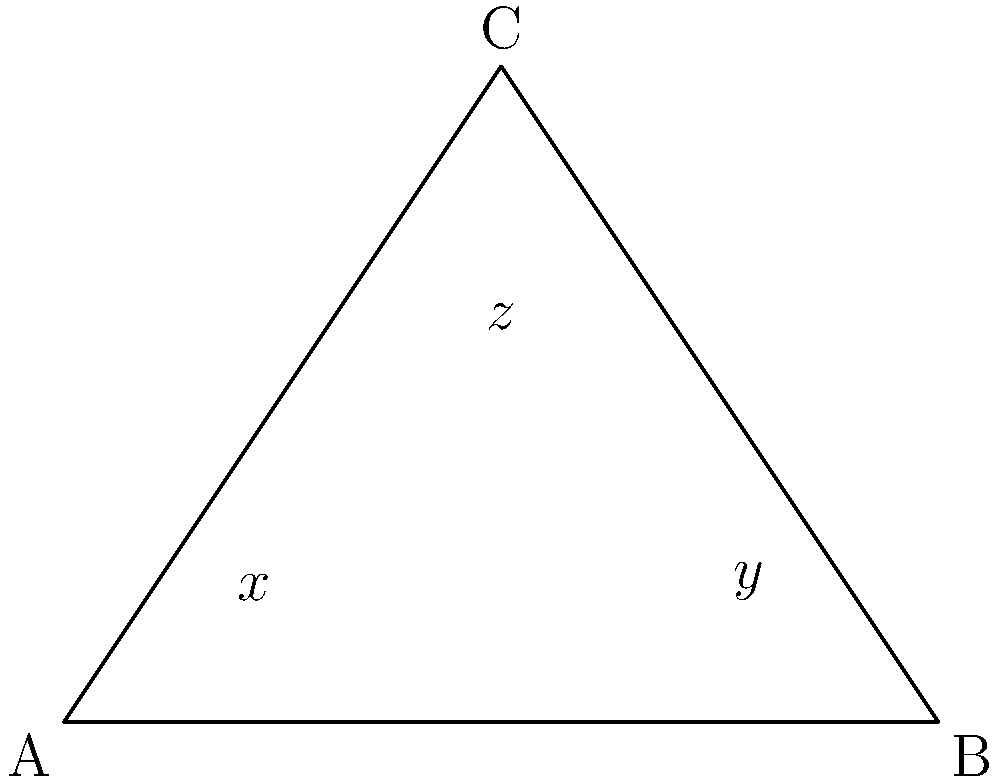In a study of marine species migration patterns affected by pollution, three paths are represented by line segments forming a triangle ABC. The pollution source is located at point C, creating two equal angles $x°$ and $y°$ at the base of the triangle. If the angle at the vertex C is $z°$, what is the value of $z$ in terms of $x$? Let's approach this step-by-step:

1) In any triangle, the sum of all angles is 180°. So we can write:
   
   $x + y + z = 180$ ... (1)

2) We're told that angles $x$ and $y$ are equal. Let's call this common value $x$. So:
   
   $x + x + z = 180$
   $2x + z = 180$ ... (2)

3) In an isosceles triangle, the base angles are equal. This means the triangle is symmetric, and the altitude from C will bisect the base AB.

4) This altitude creates two right angles at its base. Each of these right angles is composed of $x$ and half of $z$.

5) Since a right angle is 90°, we can write:
   
   $x + \frac{z}{2} = 90$
   $2x + z = 180$ ... (3)

6) Notice that equations (2) and (3) are identical. This confirms our reasoning.

7) From equation (3), we can isolate $z$:
   
   $z = 180 - 2x$

Therefore, the value of $z$ in terms of $x$ is $180 - 2x$.
Answer: $z = 180 - 2x$ 